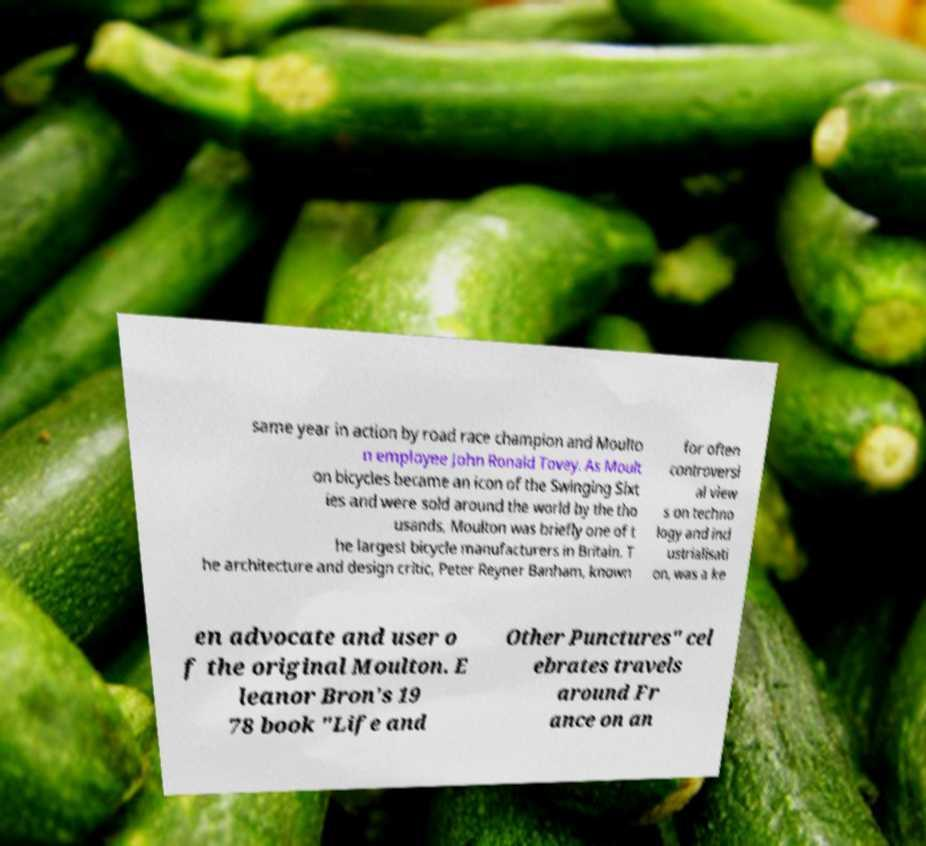I need the written content from this picture converted into text. Can you do that? same year in action by road race champion and Moulto n employee John Ronald Tovey. As Moult on bicycles became an icon of the Swinging Sixt ies and were sold around the world by the tho usands, Moulton was briefly one of t he largest bicycle manufacturers in Britain. T he architecture and design critic, Peter Reyner Banham, known for often controversi al view s on techno logy and ind ustrialisati on, was a ke en advocate and user o f the original Moulton. E leanor Bron's 19 78 book "Life and Other Punctures" cel ebrates travels around Fr ance on an 